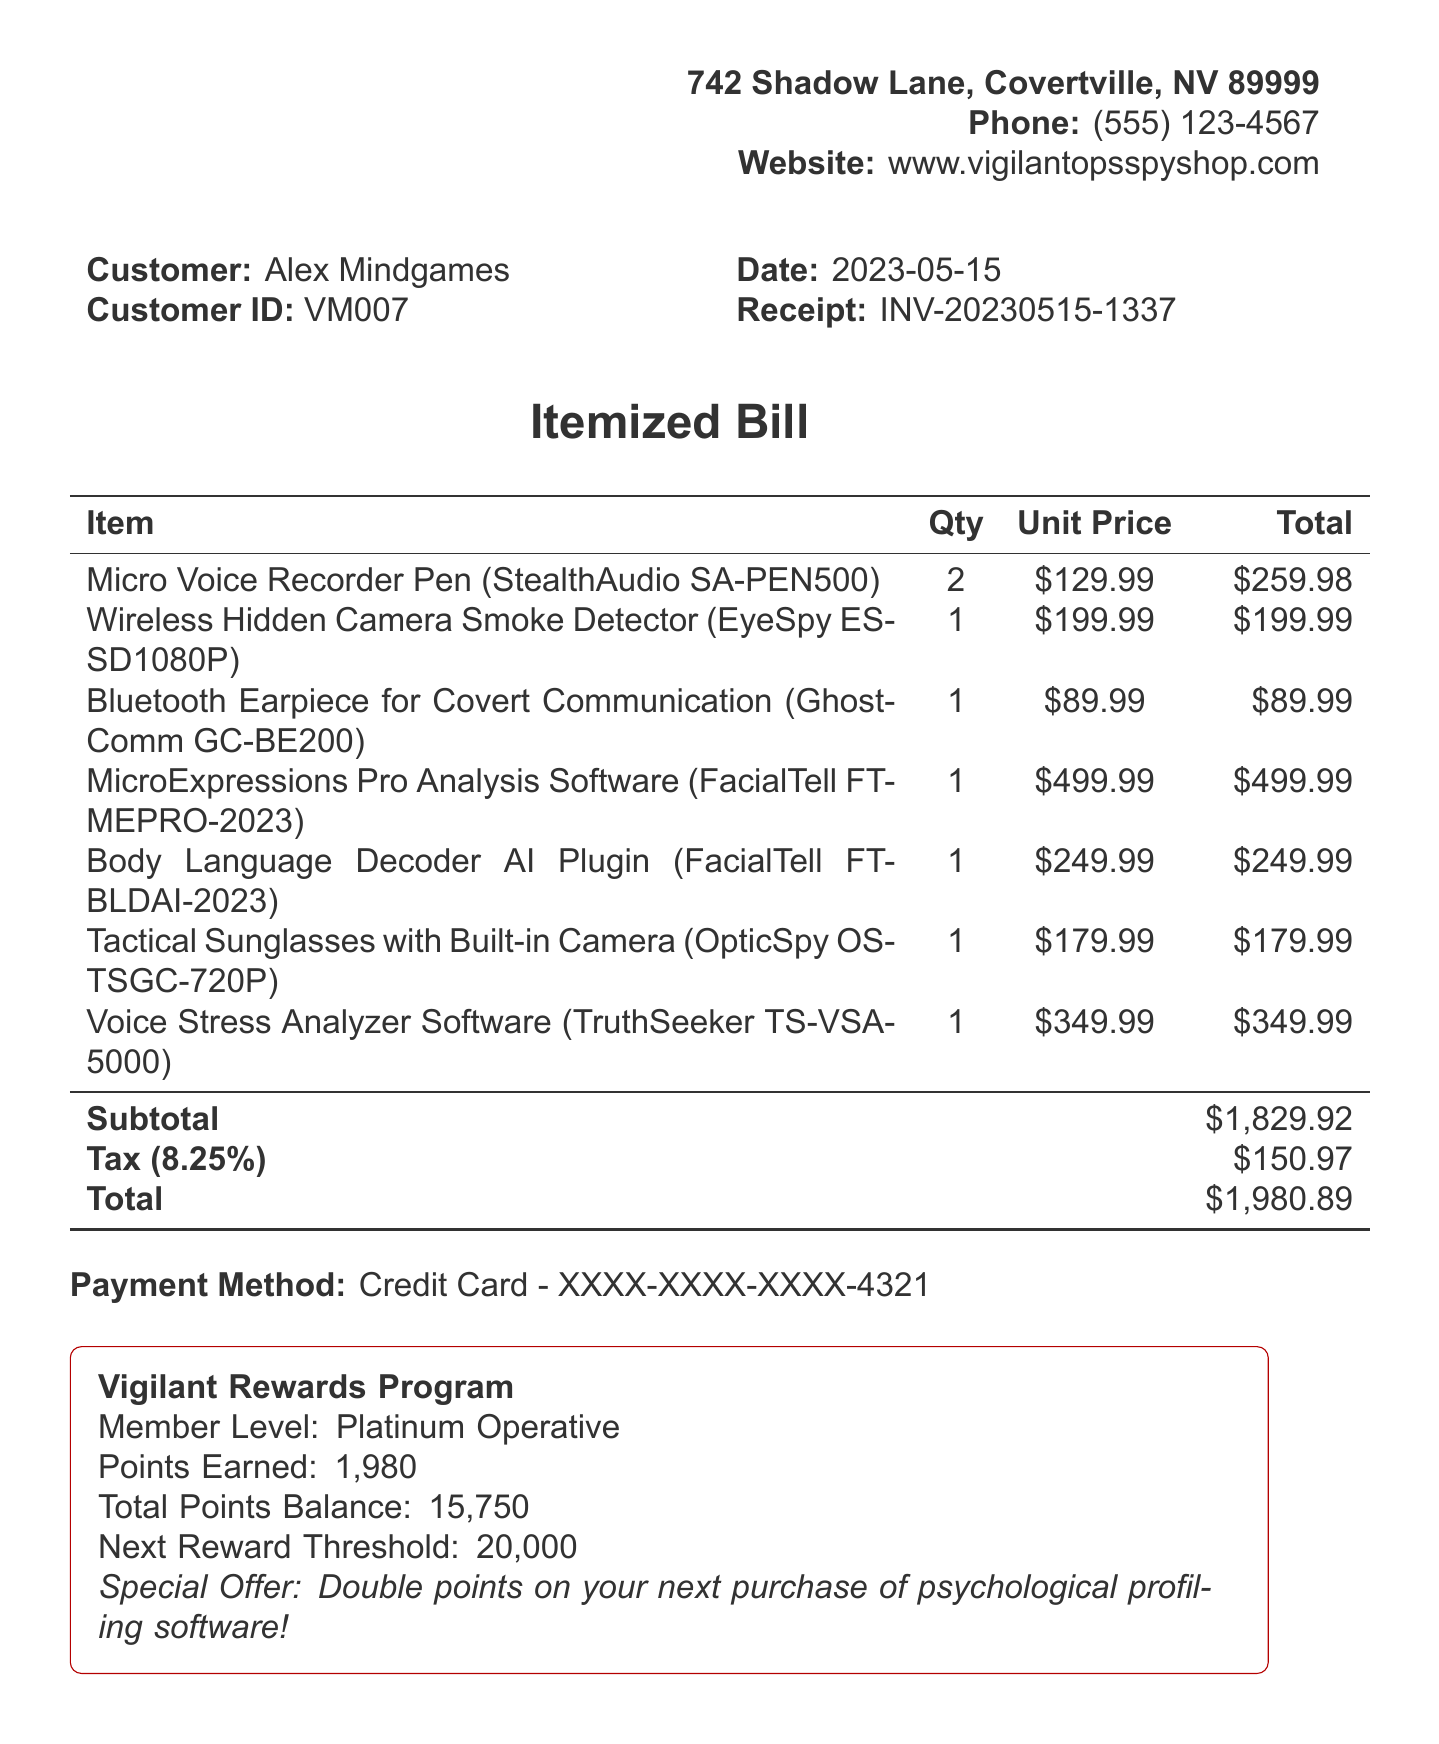What is the customer name? The customer name is specified at the top of the receipt.
Answer: Alex Mindgames What is the date of purchase? The date of purchase is noted in the receipt header.
Answer: 2023-05-15 What is the total amount of the purchase? The total amount is indicated at the bottom of the itemized bill.
Answer: $1980.89 How many Micro Voice Recorder Pens were purchased? The quantity is listed next to the item in the receipt.
Answer: 2 What is the member level in the loyalty program? The member level is stated in the loyalty program section of the receipt.
Answer: Platinum Operative What is the special offer mentioned in the loyalty program? The special offer is detailed in the loyalty program section of the receipt.
Answer: Double points on your next purchase of psychological profiling software! What is the tax rate applied to the purchase? The tax rate is noted in the subtotal section of the receipt.
Answer: 8.25% What is the return policy for software items? The return policy provides information specific to software items.
Answer: All sales final on software What is the brand of the Tactical Sunglasses? The brand is specified in the item description for the Tactical Sunglasses.
Answer: OpticSpy How many total points are in the loyalty program balance? The total points balance is indicated in the loyalty program section.
Answer: 15,750 